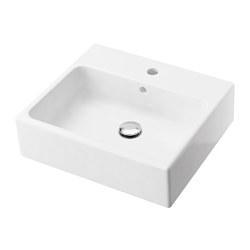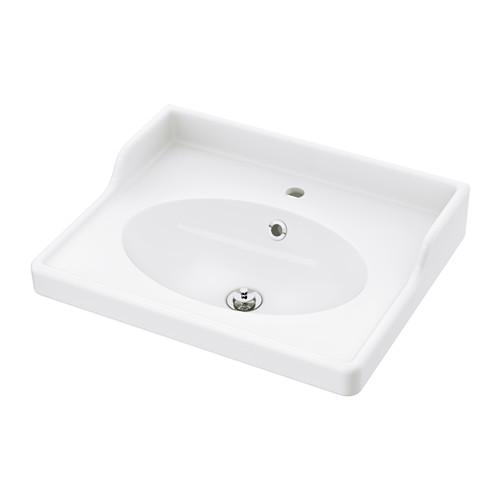The first image is the image on the left, the second image is the image on the right. For the images shown, is this caption "One of the sinks is an oval shape inset into a white rectangle, with no faucet mounted." true? Answer yes or no. Yes. The first image is the image on the left, the second image is the image on the right. Considering the images on both sides, is "The sink in the image on the left is set into a counter." valid? Answer yes or no. No. 